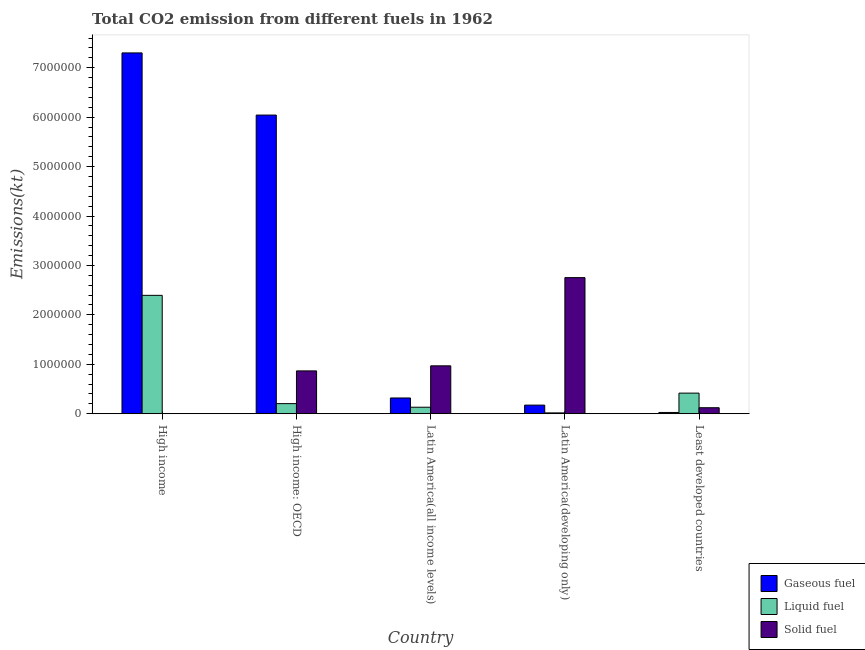How many bars are there on the 2nd tick from the right?
Your response must be concise. 3. What is the label of the 2nd group of bars from the left?
Keep it short and to the point. High income: OECD. In how many cases, is the number of bars for a given country not equal to the number of legend labels?
Offer a terse response. 0. What is the amount of co2 emissions from liquid fuel in High income?
Your response must be concise. 2.39e+06. Across all countries, what is the maximum amount of co2 emissions from liquid fuel?
Make the answer very short. 2.39e+06. Across all countries, what is the minimum amount of co2 emissions from liquid fuel?
Provide a short and direct response. 1.75e+04. In which country was the amount of co2 emissions from gaseous fuel minimum?
Keep it short and to the point. Least developed countries. What is the total amount of co2 emissions from gaseous fuel in the graph?
Give a very brief answer. 1.39e+07. What is the difference between the amount of co2 emissions from gaseous fuel in High income and that in Latin America(developing only)?
Your answer should be compact. 7.13e+06. What is the difference between the amount of co2 emissions from solid fuel in Latin America(developing only) and the amount of co2 emissions from gaseous fuel in Least developed countries?
Make the answer very short. 2.73e+06. What is the average amount of co2 emissions from liquid fuel per country?
Provide a short and direct response. 6.33e+05. What is the difference between the amount of co2 emissions from gaseous fuel and amount of co2 emissions from solid fuel in High income: OECD?
Offer a terse response. 5.18e+06. What is the ratio of the amount of co2 emissions from solid fuel in Latin America(developing only) to that in Least developed countries?
Make the answer very short. 22.66. What is the difference between the highest and the second highest amount of co2 emissions from solid fuel?
Provide a succinct answer. 1.78e+06. What is the difference between the highest and the lowest amount of co2 emissions from gaseous fuel?
Your answer should be very brief. 7.27e+06. What does the 2nd bar from the left in Latin America(all income levels) represents?
Keep it short and to the point. Liquid fuel. What does the 3rd bar from the right in Least developed countries represents?
Your response must be concise. Gaseous fuel. How many bars are there?
Your answer should be very brief. 15. Are all the bars in the graph horizontal?
Provide a short and direct response. No. What is the difference between two consecutive major ticks on the Y-axis?
Keep it short and to the point. 1.00e+06. Does the graph contain any zero values?
Give a very brief answer. No. How are the legend labels stacked?
Offer a very short reply. Vertical. What is the title of the graph?
Ensure brevity in your answer.  Total CO2 emission from different fuels in 1962. Does "Argument" appear as one of the legend labels in the graph?
Keep it short and to the point. No. What is the label or title of the Y-axis?
Your response must be concise. Emissions(kt). What is the Emissions(kt) in Gaseous fuel in High income?
Provide a succinct answer. 7.30e+06. What is the Emissions(kt) of Liquid fuel in High income?
Your answer should be compact. 2.39e+06. What is the Emissions(kt) of Solid fuel in High income?
Ensure brevity in your answer.  3311.16. What is the Emissions(kt) in Gaseous fuel in High income: OECD?
Offer a terse response. 6.04e+06. What is the Emissions(kt) of Liquid fuel in High income: OECD?
Offer a terse response. 2.05e+05. What is the Emissions(kt) of Solid fuel in High income: OECD?
Offer a very short reply. 8.67e+05. What is the Emissions(kt) in Gaseous fuel in Latin America(all income levels)?
Your response must be concise. 3.19e+05. What is the Emissions(kt) of Liquid fuel in Latin America(all income levels)?
Your answer should be compact. 1.32e+05. What is the Emissions(kt) of Solid fuel in Latin America(all income levels)?
Give a very brief answer. 9.69e+05. What is the Emissions(kt) in Gaseous fuel in Latin America(developing only)?
Give a very brief answer. 1.74e+05. What is the Emissions(kt) in Liquid fuel in Latin America(developing only)?
Your answer should be very brief. 1.75e+04. What is the Emissions(kt) in Solid fuel in Latin America(developing only)?
Provide a succinct answer. 2.75e+06. What is the Emissions(kt) in Gaseous fuel in Least developed countries?
Your answer should be very brief. 2.58e+04. What is the Emissions(kt) of Liquid fuel in Least developed countries?
Your response must be concise. 4.17e+05. What is the Emissions(kt) of Solid fuel in Least developed countries?
Provide a succinct answer. 1.22e+05. Across all countries, what is the maximum Emissions(kt) of Gaseous fuel?
Give a very brief answer. 7.30e+06. Across all countries, what is the maximum Emissions(kt) of Liquid fuel?
Provide a succinct answer. 2.39e+06. Across all countries, what is the maximum Emissions(kt) of Solid fuel?
Make the answer very short. 2.75e+06. Across all countries, what is the minimum Emissions(kt) in Gaseous fuel?
Your answer should be compact. 2.58e+04. Across all countries, what is the minimum Emissions(kt) of Liquid fuel?
Give a very brief answer. 1.75e+04. Across all countries, what is the minimum Emissions(kt) of Solid fuel?
Provide a short and direct response. 3311.16. What is the total Emissions(kt) of Gaseous fuel in the graph?
Offer a terse response. 1.39e+07. What is the total Emissions(kt) in Liquid fuel in the graph?
Your response must be concise. 3.17e+06. What is the total Emissions(kt) of Solid fuel in the graph?
Provide a short and direct response. 4.71e+06. What is the difference between the Emissions(kt) in Gaseous fuel in High income and that in High income: OECD?
Ensure brevity in your answer.  1.26e+06. What is the difference between the Emissions(kt) in Liquid fuel in High income and that in High income: OECD?
Make the answer very short. 2.19e+06. What is the difference between the Emissions(kt) in Solid fuel in High income and that in High income: OECD?
Offer a terse response. -8.63e+05. What is the difference between the Emissions(kt) of Gaseous fuel in High income and that in Latin America(all income levels)?
Offer a very short reply. 6.98e+06. What is the difference between the Emissions(kt) in Liquid fuel in High income and that in Latin America(all income levels)?
Keep it short and to the point. 2.26e+06. What is the difference between the Emissions(kt) in Solid fuel in High income and that in Latin America(all income levels)?
Provide a succinct answer. -9.66e+05. What is the difference between the Emissions(kt) in Gaseous fuel in High income and that in Latin America(developing only)?
Your response must be concise. 7.13e+06. What is the difference between the Emissions(kt) in Liquid fuel in High income and that in Latin America(developing only)?
Provide a short and direct response. 2.38e+06. What is the difference between the Emissions(kt) in Solid fuel in High income and that in Latin America(developing only)?
Provide a succinct answer. -2.75e+06. What is the difference between the Emissions(kt) of Gaseous fuel in High income and that in Least developed countries?
Provide a succinct answer. 7.27e+06. What is the difference between the Emissions(kt) in Liquid fuel in High income and that in Least developed countries?
Ensure brevity in your answer.  1.98e+06. What is the difference between the Emissions(kt) of Solid fuel in High income and that in Least developed countries?
Your answer should be compact. -1.18e+05. What is the difference between the Emissions(kt) of Gaseous fuel in High income: OECD and that in Latin America(all income levels)?
Ensure brevity in your answer.  5.72e+06. What is the difference between the Emissions(kt) of Liquid fuel in High income: OECD and that in Latin America(all income levels)?
Make the answer very short. 7.28e+04. What is the difference between the Emissions(kt) in Solid fuel in High income: OECD and that in Latin America(all income levels)?
Give a very brief answer. -1.02e+05. What is the difference between the Emissions(kt) of Gaseous fuel in High income: OECD and that in Latin America(developing only)?
Ensure brevity in your answer.  5.87e+06. What is the difference between the Emissions(kt) of Liquid fuel in High income: OECD and that in Latin America(developing only)?
Ensure brevity in your answer.  1.87e+05. What is the difference between the Emissions(kt) of Solid fuel in High income: OECD and that in Latin America(developing only)?
Provide a short and direct response. -1.89e+06. What is the difference between the Emissions(kt) in Gaseous fuel in High income: OECD and that in Least developed countries?
Offer a terse response. 6.02e+06. What is the difference between the Emissions(kt) of Liquid fuel in High income: OECD and that in Least developed countries?
Your answer should be compact. -2.13e+05. What is the difference between the Emissions(kt) in Solid fuel in High income: OECD and that in Least developed countries?
Give a very brief answer. 7.45e+05. What is the difference between the Emissions(kt) of Gaseous fuel in Latin America(all income levels) and that in Latin America(developing only)?
Offer a terse response. 1.45e+05. What is the difference between the Emissions(kt) in Liquid fuel in Latin America(all income levels) and that in Latin America(developing only)?
Give a very brief answer. 1.14e+05. What is the difference between the Emissions(kt) in Solid fuel in Latin America(all income levels) and that in Latin America(developing only)?
Ensure brevity in your answer.  -1.78e+06. What is the difference between the Emissions(kt) of Gaseous fuel in Latin America(all income levels) and that in Least developed countries?
Your answer should be compact. 2.93e+05. What is the difference between the Emissions(kt) in Liquid fuel in Latin America(all income levels) and that in Least developed countries?
Offer a very short reply. -2.85e+05. What is the difference between the Emissions(kt) in Solid fuel in Latin America(all income levels) and that in Least developed countries?
Offer a very short reply. 8.48e+05. What is the difference between the Emissions(kt) of Gaseous fuel in Latin America(developing only) and that in Least developed countries?
Provide a short and direct response. 1.48e+05. What is the difference between the Emissions(kt) of Liquid fuel in Latin America(developing only) and that in Least developed countries?
Give a very brief answer. -4.00e+05. What is the difference between the Emissions(kt) of Solid fuel in Latin America(developing only) and that in Least developed countries?
Ensure brevity in your answer.  2.63e+06. What is the difference between the Emissions(kt) in Gaseous fuel in High income and the Emissions(kt) in Liquid fuel in High income: OECD?
Ensure brevity in your answer.  7.09e+06. What is the difference between the Emissions(kt) of Gaseous fuel in High income and the Emissions(kt) of Solid fuel in High income: OECD?
Your response must be concise. 6.43e+06. What is the difference between the Emissions(kt) of Liquid fuel in High income and the Emissions(kt) of Solid fuel in High income: OECD?
Ensure brevity in your answer.  1.53e+06. What is the difference between the Emissions(kt) of Gaseous fuel in High income and the Emissions(kt) of Liquid fuel in Latin America(all income levels)?
Provide a succinct answer. 7.17e+06. What is the difference between the Emissions(kt) in Gaseous fuel in High income and the Emissions(kt) in Solid fuel in Latin America(all income levels)?
Give a very brief answer. 6.33e+06. What is the difference between the Emissions(kt) of Liquid fuel in High income and the Emissions(kt) of Solid fuel in Latin America(all income levels)?
Keep it short and to the point. 1.43e+06. What is the difference between the Emissions(kt) of Gaseous fuel in High income and the Emissions(kt) of Liquid fuel in Latin America(developing only)?
Give a very brief answer. 7.28e+06. What is the difference between the Emissions(kt) of Gaseous fuel in High income and the Emissions(kt) of Solid fuel in Latin America(developing only)?
Your answer should be very brief. 4.55e+06. What is the difference between the Emissions(kt) of Liquid fuel in High income and the Emissions(kt) of Solid fuel in Latin America(developing only)?
Provide a succinct answer. -3.59e+05. What is the difference between the Emissions(kt) in Gaseous fuel in High income and the Emissions(kt) in Liquid fuel in Least developed countries?
Ensure brevity in your answer.  6.88e+06. What is the difference between the Emissions(kt) of Gaseous fuel in High income and the Emissions(kt) of Solid fuel in Least developed countries?
Your answer should be compact. 7.18e+06. What is the difference between the Emissions(kt) in Liquid fuel in High income and the Emissions(kt) in Solid fuel in Least developed countries?
Give a very brief answer. 2.27e+06. What is the difference between the Emissions(kt) in Gaseous fuel in High income: OECD and the Emissions(kt) in Liquid fuel in Latin America(all income levels)?
Offer a very short reply. 5.91e+06. What is the difference between the Emissions(kt) in Gaseous fuel in High income: OECD and the Emissions(kt) in Solid fuel in Latin America(all income levels)?
Offer a terse response. 5.07e+06. What is the difference between the Emissions(kt) in Liquid fuel in High income: OECD and the Emissions(kt) in Solid fuel in Latin America(all income levels)?
Make the answer very short. -7.64e+05. What is the difference between the Emissions(kt) of Gaseous fuel in High income: OECD and the Emissions(kt) of Liquid fuel in Latin America(developing only)?
Ensure brevity in your answer.  6.02e+06. What is the difference between the Emissions(kt) of Gaseous fuel in High income: OECD and the Emissions(kt) of Solid fuel in Latin America(developing only)?
Make the answer very short. 3.29e+06. What is the difference between the Emissions(kt) of Liquid fuel in High income: OECD and the Emissions(kt) of Solid fuel in Latin America(developing only)?
Provide a short and direct response. -2.55e+06. What is the difference between the Emissions(kt) in Gaseous fuel in High income: OECD and the Emissions(kt) in Liquid fuel in Least developed countries?
Offer a terse response. 5.62e+06. What is the difference between the Emissions(kt) in Gaseous fuel in High income: OECD and the Emissions(kt) in Solid fuel in Least developed countries?
Provide a short and direct response. 5.92e+06. What is the difference between the Emissions(kt) of Liquid fuel in High income: OECD and the Emissions(kt) of Solid fuel in Least developed countries?
Give a very brief answer. 8.32e+04. What is the difference between the Emissions(kt) in Gaseous fuel in Latin America(all income levels) and the Emissions(kt) in Liquid fuel in Latin America(developing only)?
Your answer should be very brief. 3.01e+05. What is the difference between the Emissions(kt) of Gaseous fuel in Latin America(all income levels) and the Emissions(kt) of Solid fuel in Latin America(developing only)?
Your response must be concise. -2.43e+06. What is the difference between the Emissions(kt) in Liquid fuel in Latin America(all income levels) and the Emissions(kt) in Solid fuel in Latin America(developing only)?
Offer a terse response. -2.62e+06. What is the difference between the Emissions(kt) in Gaseous fuel in Latin America(all income levels) and the Emissions(kt) in Liquid fuel in Least developed countries?
Your answer should be very brief. -9.83e+04. What is the difference between the Emissions(kt) of Gaseous fuel in Latin America(all income levels) and the Emissions(kt) of Solid fuel in Least developed countries?
Keep it short and to the point. 1.97e+05. What is the difference between the Emissions(kt) in Liquid fuel in Latin America(all income levels) and the Emissions(kt) in Solid fuel in Least developed countries?
Ensure brevity in your answer.  1.03e+04. What is the difference between the Emissions(kt) of Gaseous fuel in Latin America(developing only) and the Emissions(kt) of Liquid fuel in Least developed countries?
Provide a succinct answer. -2.43e+05. What is the difference between the Emissions(kt) in Gaseous fuel in Latin America(developing only) and the Emissions(kt) in Solid fuel in Least developed countries?
Ensure brevity in your answer.  5.27e+04. What is the difference between the Emissions(kt) of Liquid fuel in Latin America(developing only) and the Emissions(kt) of Solid fuel in Least developed countries?
Your response must be concise. -1.04e+05. What is the average Emissions(kt) of Gaseous fuel per country?
Ensure brevity in your answer.  2.77e+06. What is the average Emissions(kt) of Liquid fuel per country?
Provide a short and direct response. 6.33e+05. What is the average Emissions(kt) in Solid fuel per country?
Make the answer very short. 9.43e+05. What is the difference between the Emissions(kt) of Gaseous fuel and Emissions(kt) of Liquid fuel in High income?
Give a very brief answer. 4.90e+06. What is the difference between the Emissions(kt) of Gaseous fuel and Emissions(kt) of Solid fuel in High income?
Your answer should be compact. 7.30e+06. What is the difference between the Emissions(kt) of Liquid fuel and Emissions(kt) of Solid fuel in High income?
Your response must be concise. 2.39e+06. What is the difference between the Emissions(kt) of Gaseous fuel and Emissions(kt) of Liquid fuel in High income: OECD?
Keep it short and to the point. 5.84e+06. What is the difference between the Emissions(kt) of Gaseous fuel and Emissions(kt) of Solid fuel in High income: OECD?
Your response must be concise. 5.18e+06. What is the difference between the Emissions(kt) in Liquid fuel and Emissions(kt) in Solid fuel in High income: OECD?
Make the answer very short. -6.62e+05. What is the difference between the Emissions(kt) in Gaseous fuel and Emissions(kt) in Liquid fuel in Latin America(all income levels)?
Your response must be concise. 1.87e+05. What is the difference between the Emissions(kt) of Gaseous fuel and Emissions(kt) of Solid fuel in Latin America(all income levels)?
Provide a short and direct response. -6.50e+05. What is the difference between the Emissions(kt) in Liquid fuel and Emissions(kt) in Solid fuel in Latin America(all income levels)?
Your response must be concise. -8.37e+05. What is the difference between the Emissions(kt) of Gaseous fuel and Emissions(kt) of Liquid fuel in Latin America(developing only)?
Ensure brevity in your answer.  1.57e+05. What is the difference between the Emissions(kt) in Gaseous fuel and Emissions(kt) in Solid fuel in Latin America(developing only)?
Your response must be concise. -2.58e+06. What is the difference between the Emissions(kt) in Liquid fuel and Emissions(kt) in Solid fuel in Latin America(developing only)?
Your response must be concise. -2.74e+06. What is the difference between the Emissions(kt) of Gaseous fuel and Emissions(kt) of Liquid fuel in Least developed countries?
Provide a succinct answer. -3.91e+05. What is the difference between the Emissions(kt) of Gaseous fuel and Emissions(kt) of Solid fuel in Least developed countries?
Your answer should be very brief. -9.57e+04. What is the difference between the Emissions(kt) of Liquid fuel and Emissions(kt) of Solid fuel in Least developed countries?
Your answer should be very brief. 2.96e+05. What is the ratio of the Emissions(kt) of Gaseous fuel in High income to that in High income: OECD?
Ensure brevity in your answer.  1.21. What is the ratio of the Emissions(kt) in Liquid fuel in High income to that in High income: OECD?
Make the answer very short. 11.7. What is the ratio of the Emissions(kt) in Solid fuel in High income to that in High income: OECD?
Your answer should be very brief. 0. What is the ratio of the Emissions(kt) of Gaseous fuel in High income to that in Latin America(all income levels)?
Provide a short and direct response. 22.89. What is the ratio of the Emissions(kt) of Liquid fuel in High income to that in Latin America(all income levels)?
Keep it short and to the point. 18.16. What is the ratio of the Emissions(kt) in Solid fuel in High income to that in Latin America(all income levels)?
Your answer should be very brief. 0. What is the ratio of the Emissions(kt) of Gaseous fuel in High income to that in Latin America(developing only)?
Provide a short and direct response. 41.89. What is the ratio of the Emissions(kt) in Liquid fuel in High income to that in Latin America(developing only)?
Your answer should be compact. 137.13. What is the ratio of the Emissions(kt) in Solid fuel in High income to that in Latin America(developing only)?
Offer a terse response. 0. What is the ratio of the Emissions(kt) in Gaseous fuel in High income to that in Least developed countries?
Keep it short and to the point. 282.92. What is the ratio of the Emissions(kt) in Liquid fuel in High income to that in Least developed countries?
Your response must be concise. 5.74. What is the ratio of the Emissions(kt) in Solid fuel in High income to that in Least developed countries?
Your answer should be compact. 0.03. What is the ratio of the Emissions(kt) in Gaseous fuel in High income: OECD to that in Latin America(all income levels)?
Your answer should be very brief. 18.94. What is the ratio of the Emissions(kt) of Liquid fuel in High income: OECD to that in Latin America(all income levels)?
Your response must be concise. 1.55. What is the ratio of the Emissions(kt) of Solid fuel in High income: OECD to that in Latin America(all income levels)?
Your response must be concise. 0.89. What is the ratio of the Emissions(kt) in Gaseous fuel in High income: OECD to that in Latin America(developing only)?
Your answer should be very brief. 34.67. What is the ratio of the Emissions(kt) in Liquid fuel in High income: OECD to that in Latin America(developing only)?
Give a very brief answer. 11.72. What is the ratio of the Emissions(kt) of Solid fuel in High income: OECD to that in Latin America(developing only)?
Provide a short and direct response. 0.31. What is the ratio of the Emissions(kt) of Gaseous fuel in High income: OECD to that in Least developed countries?
Offer a very short reply. 234.19. What is the ratio of the Emissions(kt) in Liquid fuel in High income: OECD to that in Least developed countries?
Your answer should be compact. 0.49. What is the ratio of the Emissions(kt) in Solid fuel in High income: OECD to that in Least developed countries?
Offer a terse response. 7.13. What is the ratio of the Emissions(kt) in Gaseous fuel in Latin America(all income levels) to that in Latin America(developing only)?
Offer a terse response. 1.83. What is the ratio of the Emissions(kt) of Liquid fuel in Latin America(all income levels) to that in Latin America(developing only)?
Provide a short and direct response. 7.55. What is the ratio of the Emissions(kt) in Solid fuel in Latin America(all income levels) to that in Latin America(developing only)?
Offer a very short reply. 0.35. What is the ratio of the Emissions(kt) of Gaseous fuel in Latin America(all income levels) to that in Least developed countries?
Provide a short and direct response. 12.36. What is the ratio of the Emissions(kt) in Liquid fuel in Latin America(all income levels) to that in Least developed countries?
Keep it short and to the point. 0.32. What is the ratio of the Emissions(kt) of Solid fuel in Latin America(all income levels) to that in Least developed countries?
Your answer should be compact. 7.97. What is the ratio of the Emissions(kt) in Gaseous fuel in Latin America(developing only) to that in Least developed countries?
Provide a succinct answer. 6.75. What is the ratio of the Emissions(kt) in Liquid fuel in Latin America(developing only) to that in Least developed countries?
Keep it short and to the point. 0.04. What is the ratio of the Emissions(kt) of Solid fuel in Latin America(developing only) to that in Least developed countries?
Your response must be concise. 22.66. What is the difference between the highest and the second highest Emissions(kt) of Gaseous fuel?
Provide a succinct answer. 1.26e+06. What is the difference between the highest and the second highest Emissions(kt) in Liquid fuel?
Keep it short and to the point. 1.98e+06. What is the difference between the highest and the second highest Emissions(kt) in Solid fuel?
Provide a short and direct response. 1.78e+06. What is the difference between the highest and the lowest Emissions(kt) in Gaseous fuel?
Provide a short and direct response. 7.27e+06. What is the difference between the highest and the lowest Emissions(kt) of Liquid fuel?
Ensure brevity in your answer.  2.38e+06. What is the difference between the highest and the lowest Emissions(kt) of Solid fuel?
Your answer should be very brief. 2.75e+06. 